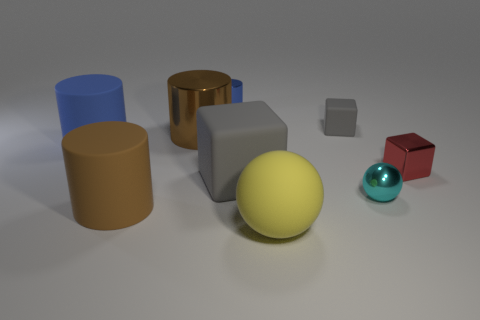Add 1 metallic cylinders. How many objects exist? 10 Subtract all yellow cylinders. Subtract all red cubes. How many cylinders are left? 4 Subtract all cylinders. How many objects are left? 5 Add 5 yellow rubber objects. How many yellow rubber objects exist? 6 Subtract 0 green cylinders. How many objects are left? 9 Subtract all large gray rubber objects. Subtract all tiny shiny objects. How many objects are left? 5 Add 3 big gray rubber cubes. How many big gray rubber cubes are left? 4 